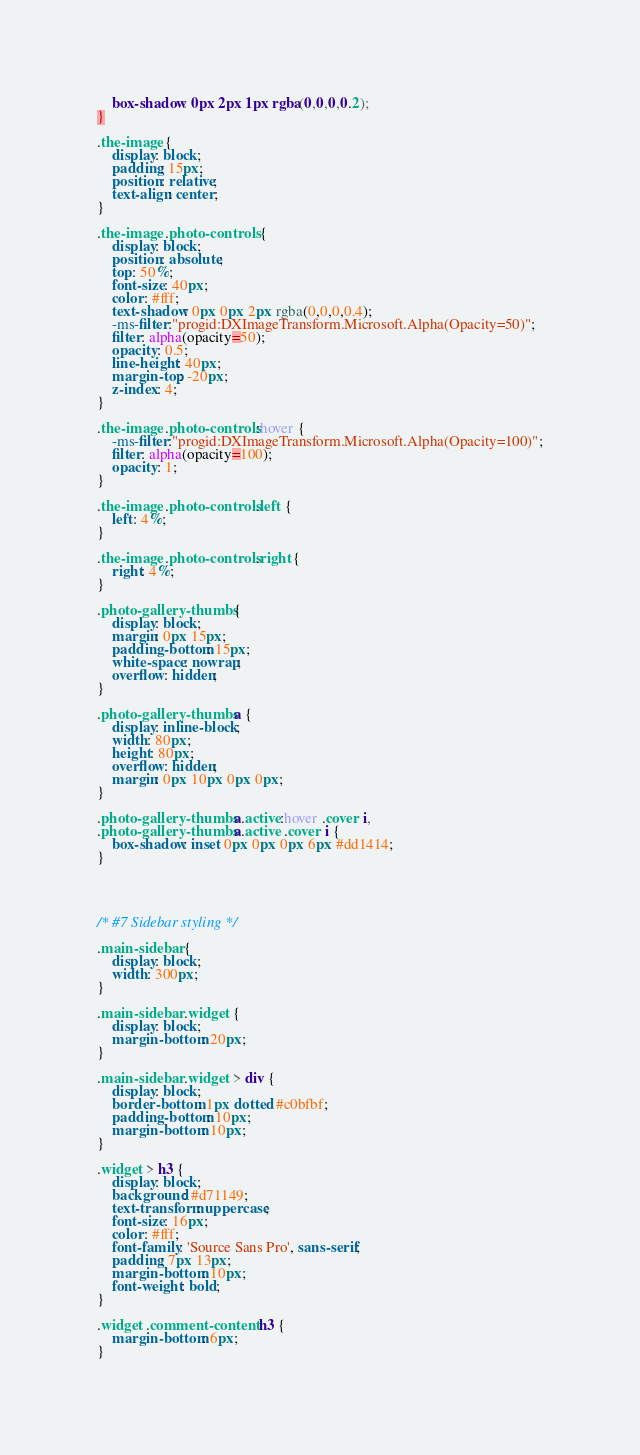Convert code to text. <code><loc_0><loc_0><loc_500><loc_500><_CSS_>	box-shadow: 0px 2px 1px rgba(0,0,0,0.2);
}

.the-image {
	display: block;
	padding: 15px;
	position: relative;
	text-align: center;
}

.the-image .photo-controls {
	display: block;
	position: absolute;
	top: 50%;
	font-size: 40px;
	color: #fff;
	text-shadow: 0px 0px 2px rgba(0,0,0,0.4);
	-ms-filter:"progid:DXImageTransform.Microsoft.Alpha(Opacity=50)";
	filter: alpha(opacity=50);
	opacity: 0.5;
	line-height: 40px;
	margin-top: -20px;
	z-index: 4;
}

.the-image .photo-controls:hover {
	-ms-filter:"progid:DXImageTransform.Microsoft.Alpha(Opacity=100)";
	filter: alpha(opacity=100);
	opacity: 1;
}

.the-image .photo-controls.left {
	left: 4%;
}

.the-image .photo-controls.right {
	right: 4%;
}

.photo-gallery-thumbs {
	display: block;
	margin: 0px 15px;
	padding-bottom: 15px;
	white-space: nowrap;
	overflow: hidden;
}

.photo-gallery-thumbs a {
	display: inline-block;
	width: 80px;
	height: 80px;
	overflow: hidden;
	margin: 0px 10px 0px 0px;
}

.photo-gallery-thumbs a.active:hover .cover i,
.photo-gallery-thumbs a.active .cover i {
	box-shadow: inset 0px 0px 0px 6px #dd1414;
}




/* #7 Sidebar styling */

.main-sidebar {
	display: block;
	width: 300px;
}

.main-sidebar .widget {
	display: block;
	margin-bottom: 20px;
}

.main-sidebar .widget > div {
	display: block;
	border-bottom: 1px dotted #c0bfbf;
	padding-bottom: 10px;
	margin-bottom: 10px;
}

.widget > h3 {
	display: block;
	background: #d71149;
	text-transform: uppercase;
	font-size: 16px;
	color: #fff;
	font-family: 'Source Sans Pro', sans-serif;
	padding: 7px 13px;
	margin-bottom: 10px;
	font-weight: bold;
}

.widget .comment-content h3 {
	margin-bottom: 6px;
}
</code> 